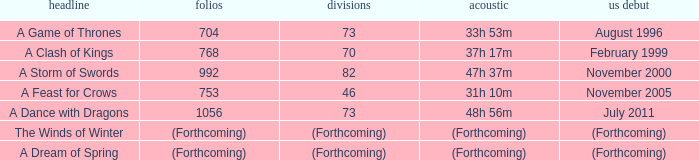Which title has a US release of august 1996? A Game of Thrones. 